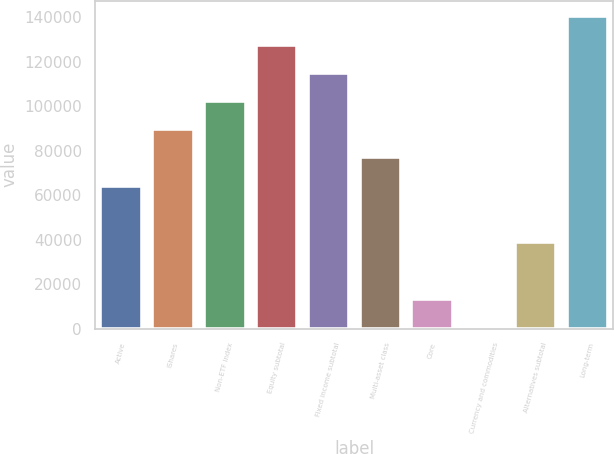<chart> <loc_0><loc_0><loc_500><loc_500><bar_chart><fcel>Active<fcel>iShares<fcel>Non-ETF index<fcel>Equity subtotal<fcel>Fixed income subtotal<fcel>Multi-asset class<fcel>Core<fcel>Currency and commodities<fcel>Alternatives subtotal<fcel>Long-term<nl><fcel>64194.5<fcel>89577.1<fcel>102268<fcel>127651<fcel>114960<fcel>76885.8<fcel>13429.3<fcel>738<fcel>38811.9<fcel>140342<nl></chart> 